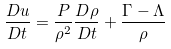<formula> <loc_0><loc_0><loc_500><loc_500>\frac { D u } { D t } = \frac { P } { \rho ^ { 2 } } \frac { D \rho } { D t } + \frac { \Gamma - \Lambda } { \rho }</formula> 